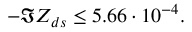Convert formula to latex. <formula><loc_0><loc_0><loc_500><loc_500>- \Im Z _ { d s } \leq 5 . 6 6 \cdot 1 0 ^ { - 4 } .</formula> 